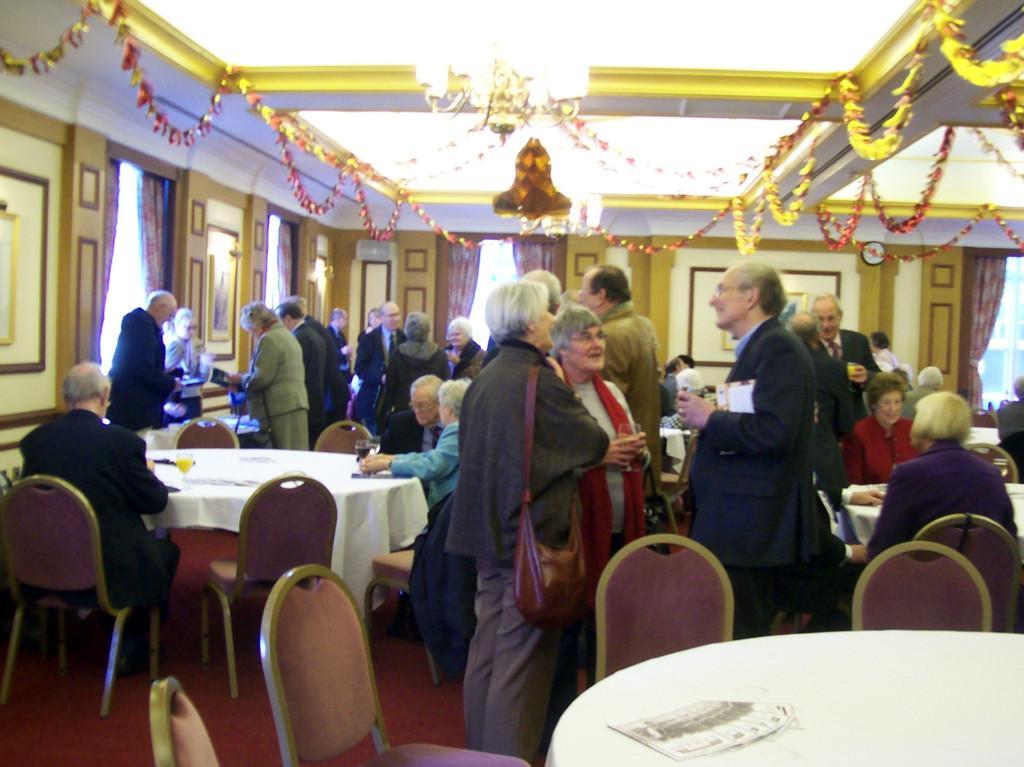How would you summarize this image in a sentence or two? In this image there are group of people standing there are few chair and tables, at the back ground there is a wall and the frame attached to a wall at the top there is a light. 